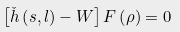Convert formula to latex. <formula><loc_0><loc_0><loc_500><loc_500>\left [ \check { h } \left ( s , l \right ) - W \right ] F \left ( \rho \right ) = 0</formula> 